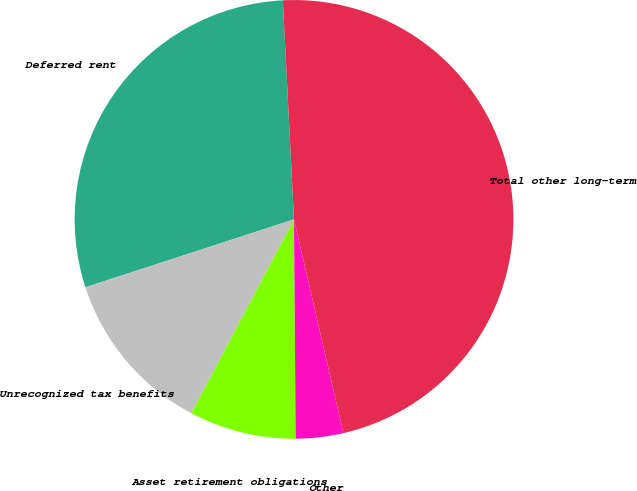Convert chart to OTSL. <chart><loc_0><loc_0><loc_500><loc_500><pie_chart><fcel>Deferred rent<fcel>Unrecognized tax benefits<fcel>Asset retirement obligations<fcel>Other<fcel>Total other long-term<nl><fcel>29.2%<fcel>12.24%<fcel>7.87%<fcel>3.5%<fcel>47.19%<nl></chart> 